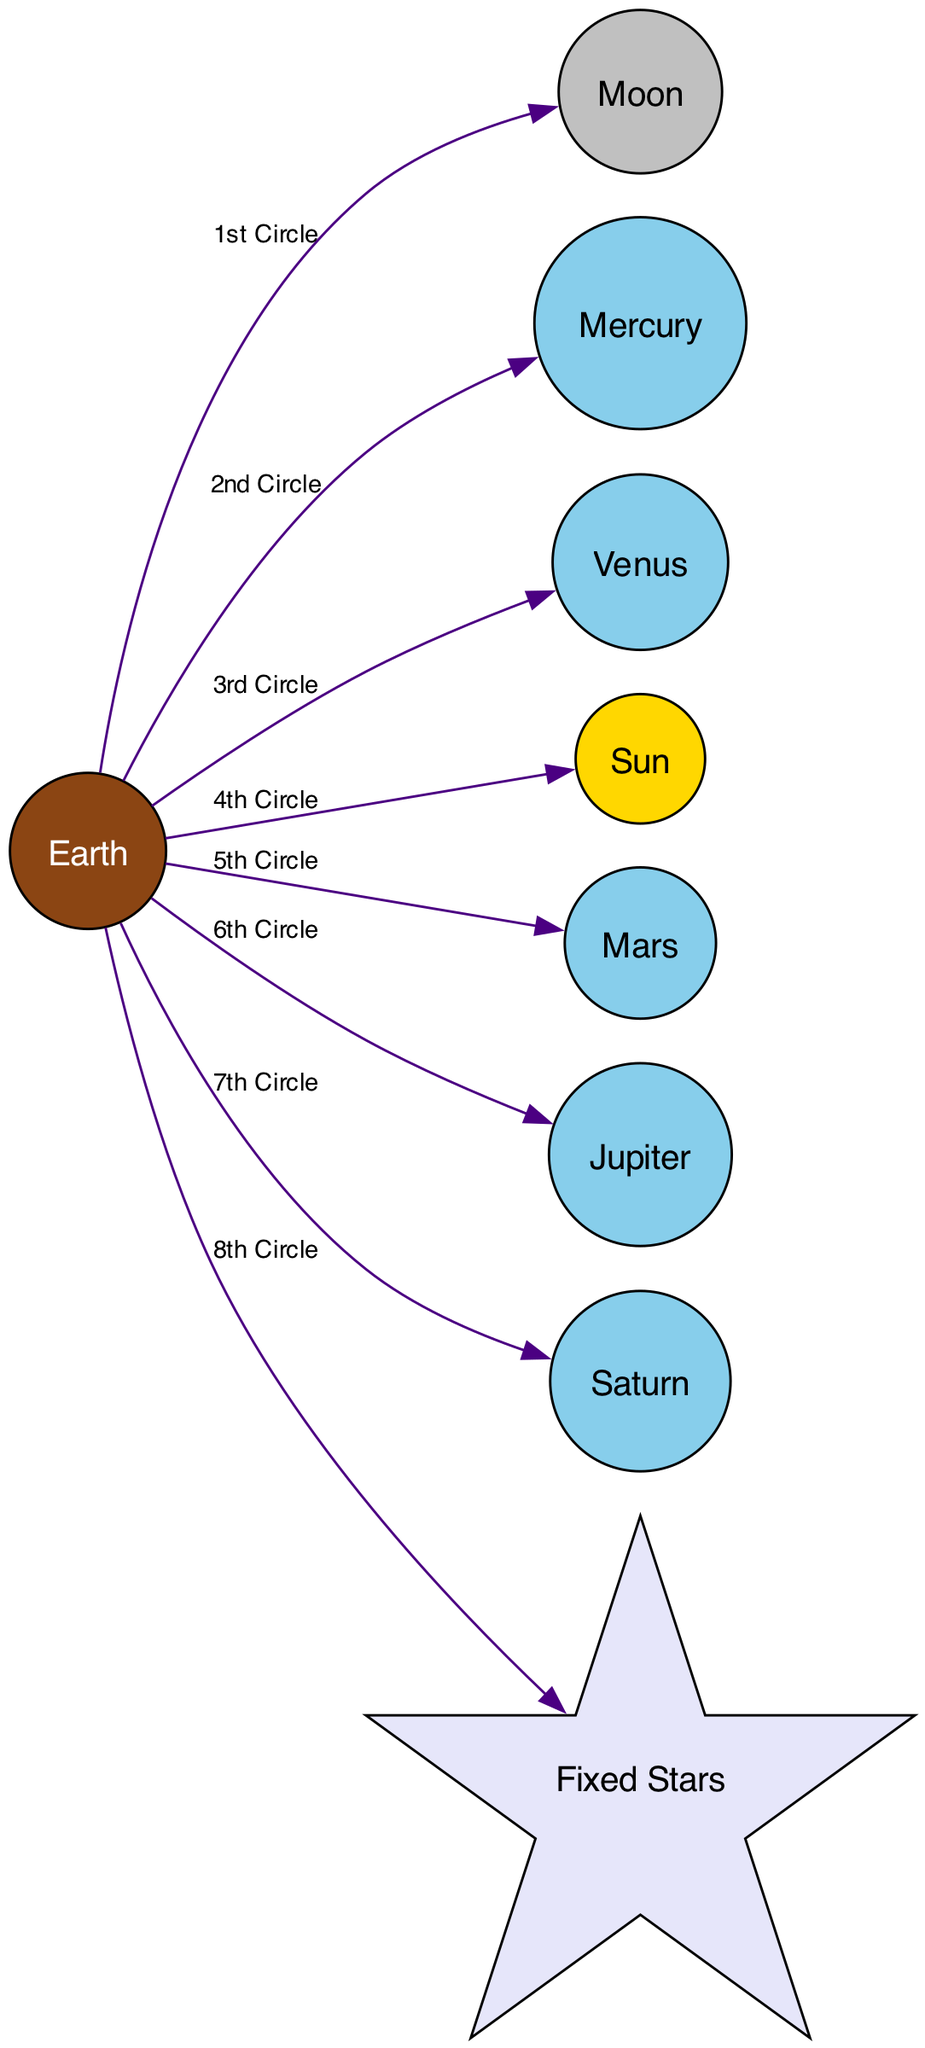What is the central body in the Ptolemaic model? The diagram clearly denotes the Earth as the central body in the Ptolemaic model, indicated by its unique label and description.
Answer: Earth What orbits Earth as the closest celestial body? The diagram specifically designates the Moon as the closest celestial body that orbits around Earth, which is directly connected with an edge labeled "1st Circle."
Answer: Moon Which is the fifth planet from Earth according to the diagram? Analyzing the nodes in order from the central Earth node, Jupiter is shown as the fifth celestial body connected by an edge labeled "6th Circle."
Answer: Jupiter How many circles are depicted in the diagram? The diagram features eight edges leading out from Earth to other celestial bodies, each labeled with a corresponding circle number, such that the count of circles is eight.
Answer: 8 Which celestial body is represented with a star shape in the diagram? A close look at the nodes reveals that the Fixed Stars are represented with a distinctive star shape, emphasizing their unique position in the model.
Answer: Fixed Stars What is the relationship between Earth and the Sun in the diagram? The diagram illustrates that the Sun orbits Earth, connected directly to it by an edge labeled "4th Circle," indicating a close association in the geocentric model.
Answer: Orbits List the order of planets from Earth outward as shown in the diagram. The diagram displays the order of planets outward from Earth as follows: Mercury (2nd Circle), Venus (3rd Circle), Mars (5th Circle), Jupiter (6th Circle), Saturn (7th Circle).
Answer: Mercury, Venus, Mars, Jupiter, Saturn What color is used to represent the Sun in the diagram? The Sun is uniquely represented in the diagram with a golden yellow fill color and black font, setting it apart from other celestial bodies.
Answer: Golden yellow Which celestial body is the sixth in the order from Earth according to the diagram? By examining the ordered list of celestial bodies connected to Earth, Saturn is identified as the sixth body in Ptolemy's model, linked to Earth by the "7th Circle."
Answer: Saturn 